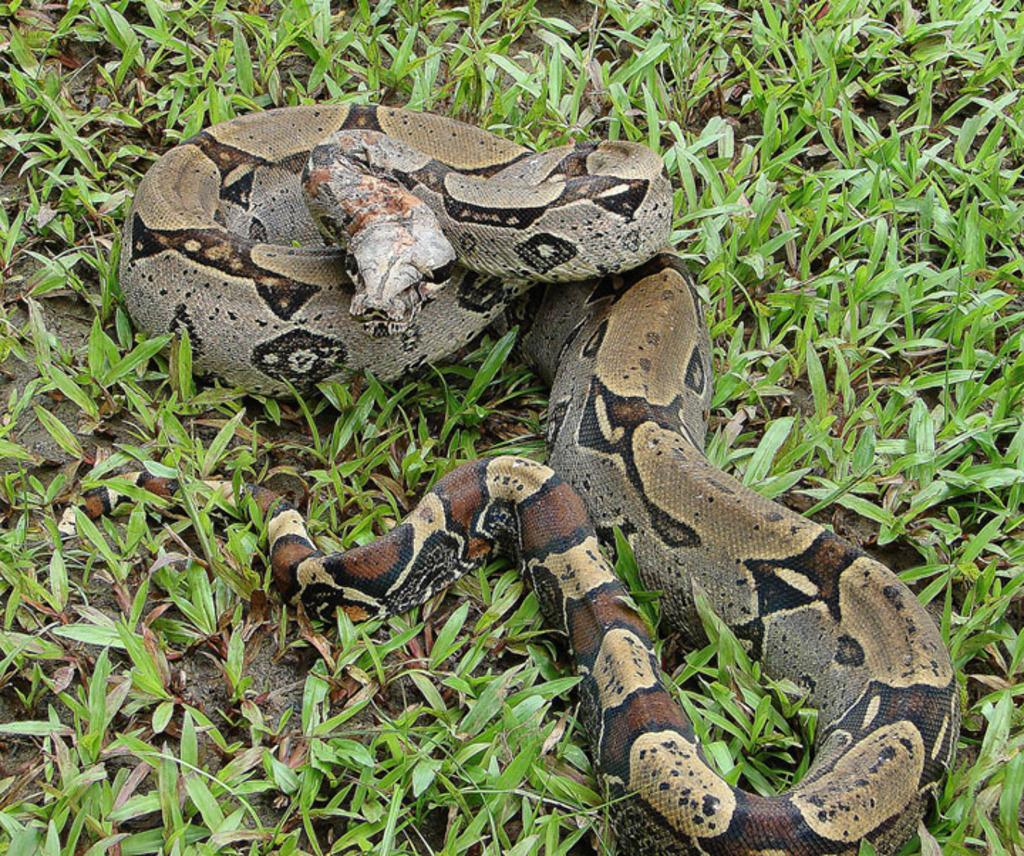What type of animal is in the image? There is a snake in the image. What type of vegetation is present in the image? There is grass in the image. What type of quince can be seen growing in the image? There is no quince present in the image; it only features a snake and grass. 